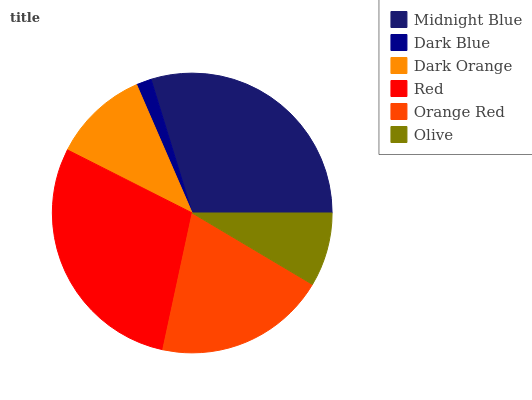Is Dark Blue the minimum?
Answer yes or no. Yes. Is Midnight Blue the maximum?
Answer yes or no. Yes. Is Dark Orange the minimum?
Answer yes or no. No. Is Dark Orange the maximum?
Answer yes or no. No. Is Dark Orange greater than Dark Blue?
Answer yes or no. Yes. Is Dark Blue less than Dark Orange?
Answer yes or no. Yes. Is Dark Blue greater than Dark Orange?
Answer yes or no. No. Is Dark Orange less than Dark Blue?
Answer yes or no. No. Is Orange Red the high median?
Answer yes or no. Yes. Is Dark Orange the low median?
Answer yes or no. Yes. Is Dark Blue the high median?
Answer yes or no. No. Is Red the low median?
Answer yes or no. No. 